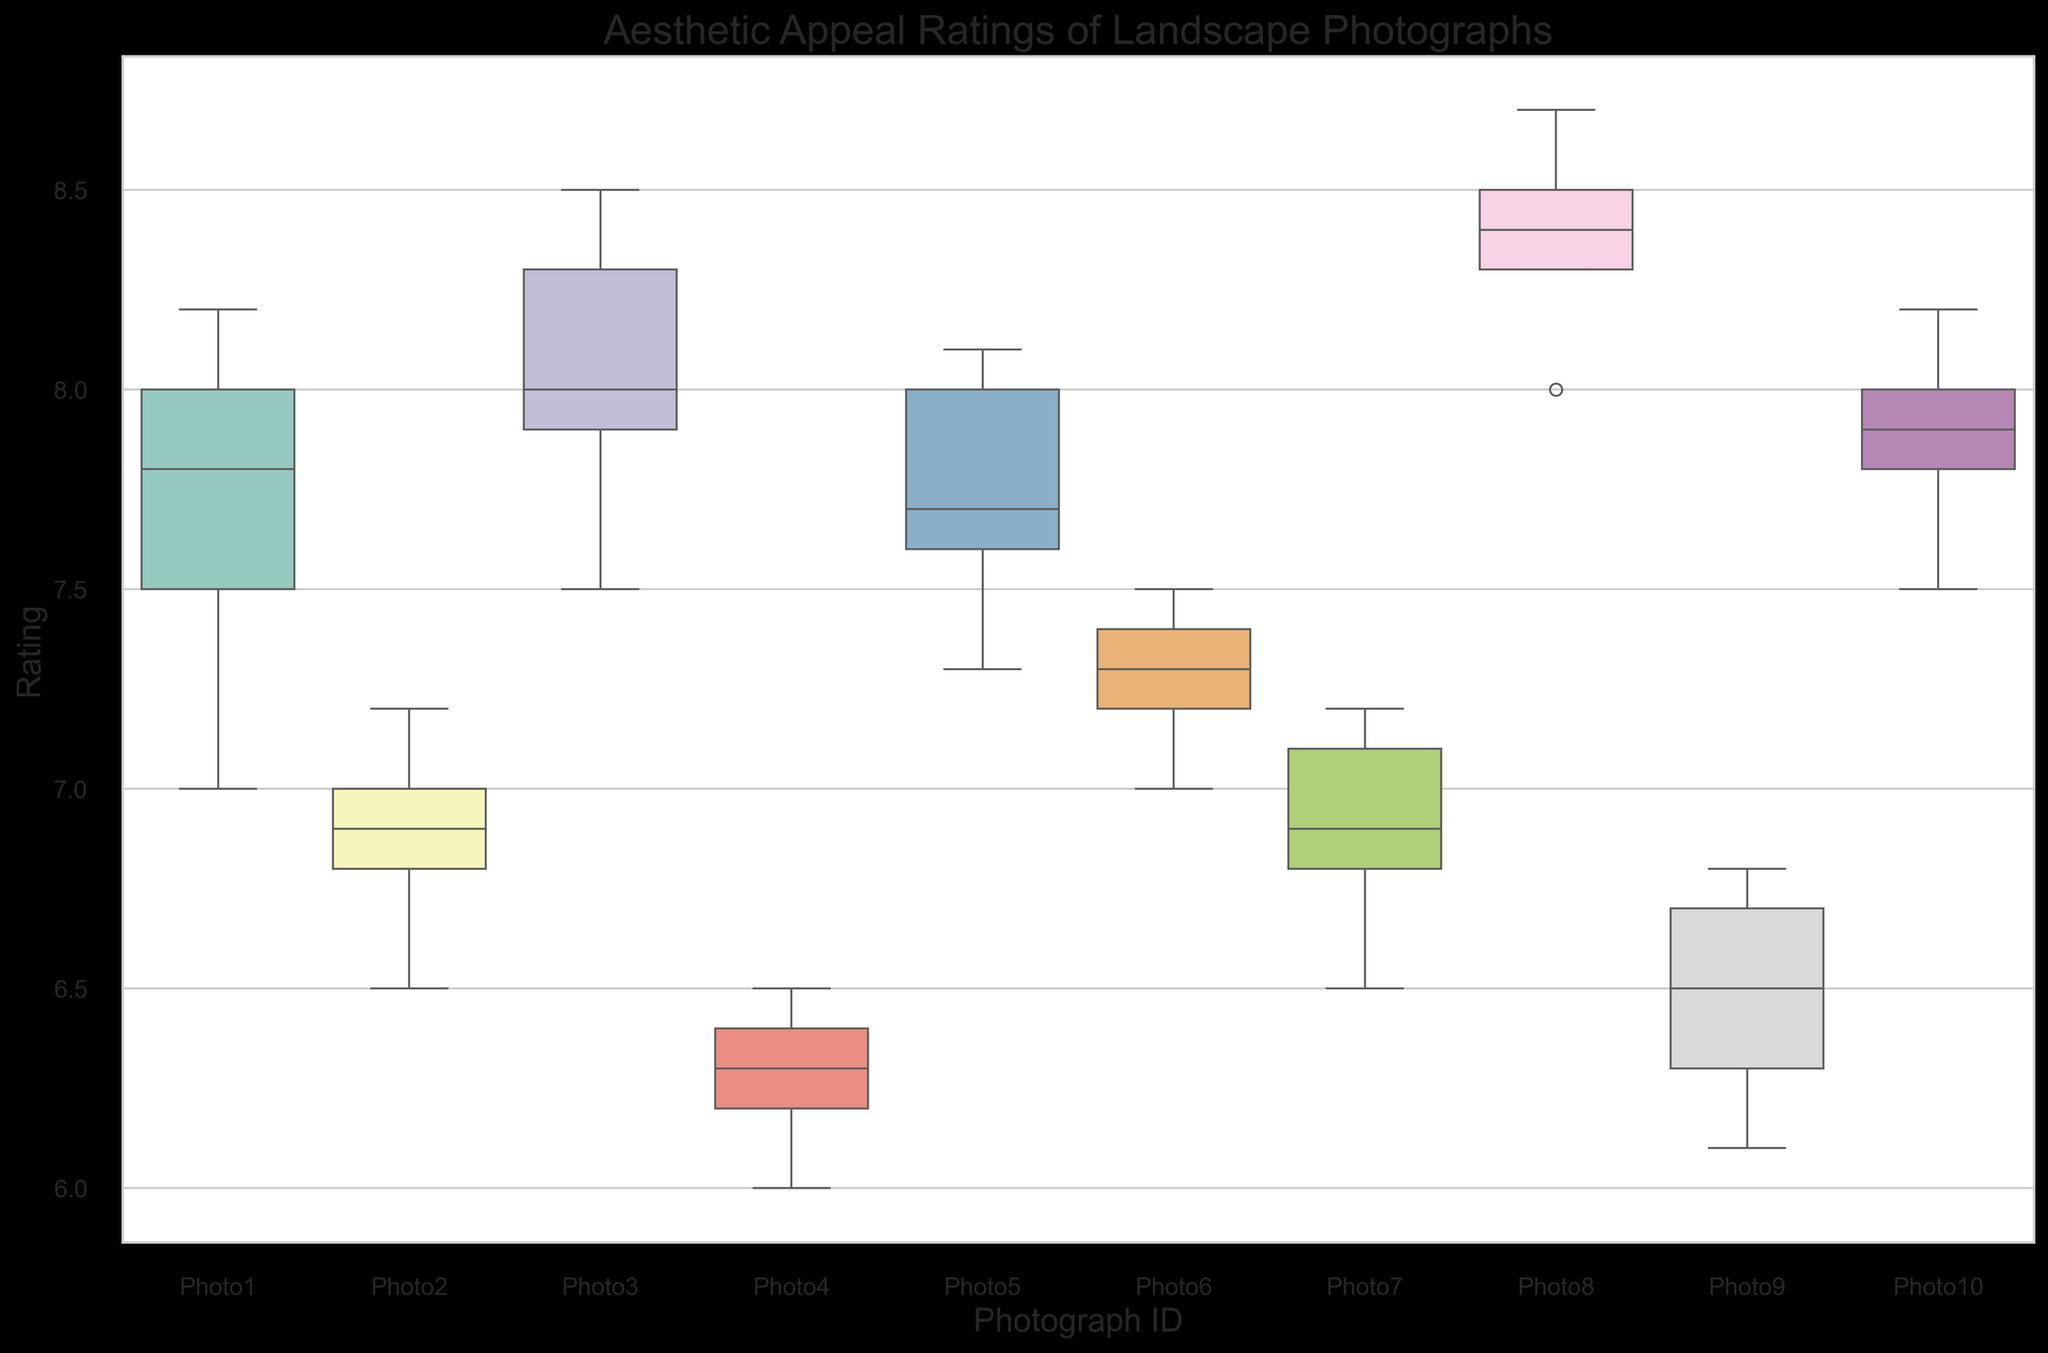What is the median rating for Photo1? Locate the box associated with Photo1. The thick line inside the box represents the median rating.
Answer: 7.8 Which photograph received the lowest median rating and what is the value? Look at the boxplots and identify the one with the lowest thick line, which is the median value.
Answer: Photo4, 6.3 What is the range of ratings for Photo8? Identify the minimum and maximum values indicated by the whiskers (the ends of the lines extending from the boxes) for Photo8 and subtract the minimum from the maximum. Max is 8.7 and Min is 8.0.
Answer: 0.7 Which photo has the smallest interquartile range (IQR) and what is its value? The IQR is the length of the box, representing the middle 50% of the data. Find the shortest box among all the plots and look at the IQR.
Answer: Photo4, 0.4 Compare the median ratings of Photo3 and Photo5. Which one is higher? Find the thick lines within the boxes for Photo3 and Photo5 and compare their positions. Photo3's median is 8.0 and Photo5's median is 7.7.
Answer: Photo3 What is the difference between the highest and the lowest median ratings across the photographs? Identify the highest and lowest medians among all photographs. For highest, Photo8's median is 8.4 and for lowest, Photo4's median is 6.3. Subtract the lowest median from the highest median. 8.4 - 6.3 = 2.1
Answer: 2.1 For which photograph is the spread of ratings (variance) the largest? The spread, or variance, can be visually estimated by the length of the whiskers and the box. Identify the photograph with the largest combined length of whiskers and box.
Answer: Photo9 How does the median rating of Photo2 compare to Photo7? Look at the thick lines inside the boxes for both Photo2 and Photo7 and see which one is higher. Photo2's median is 6.9 and Photo7's median is 6.9.
Answer: They are equal What is the 75th percentile rating for Photo3? The top boundary of the box represents the 75th percentile, locate it on the plot for Photo3.
Answer: 8.3 Which photograph exhibits the greatest overall rating overlap (similarity in range) with Photo6? Compare the whisker-to-whisker ranges of each photograph and find the one most closely overlapping with the range of Photo6.
Answer: Photo7 